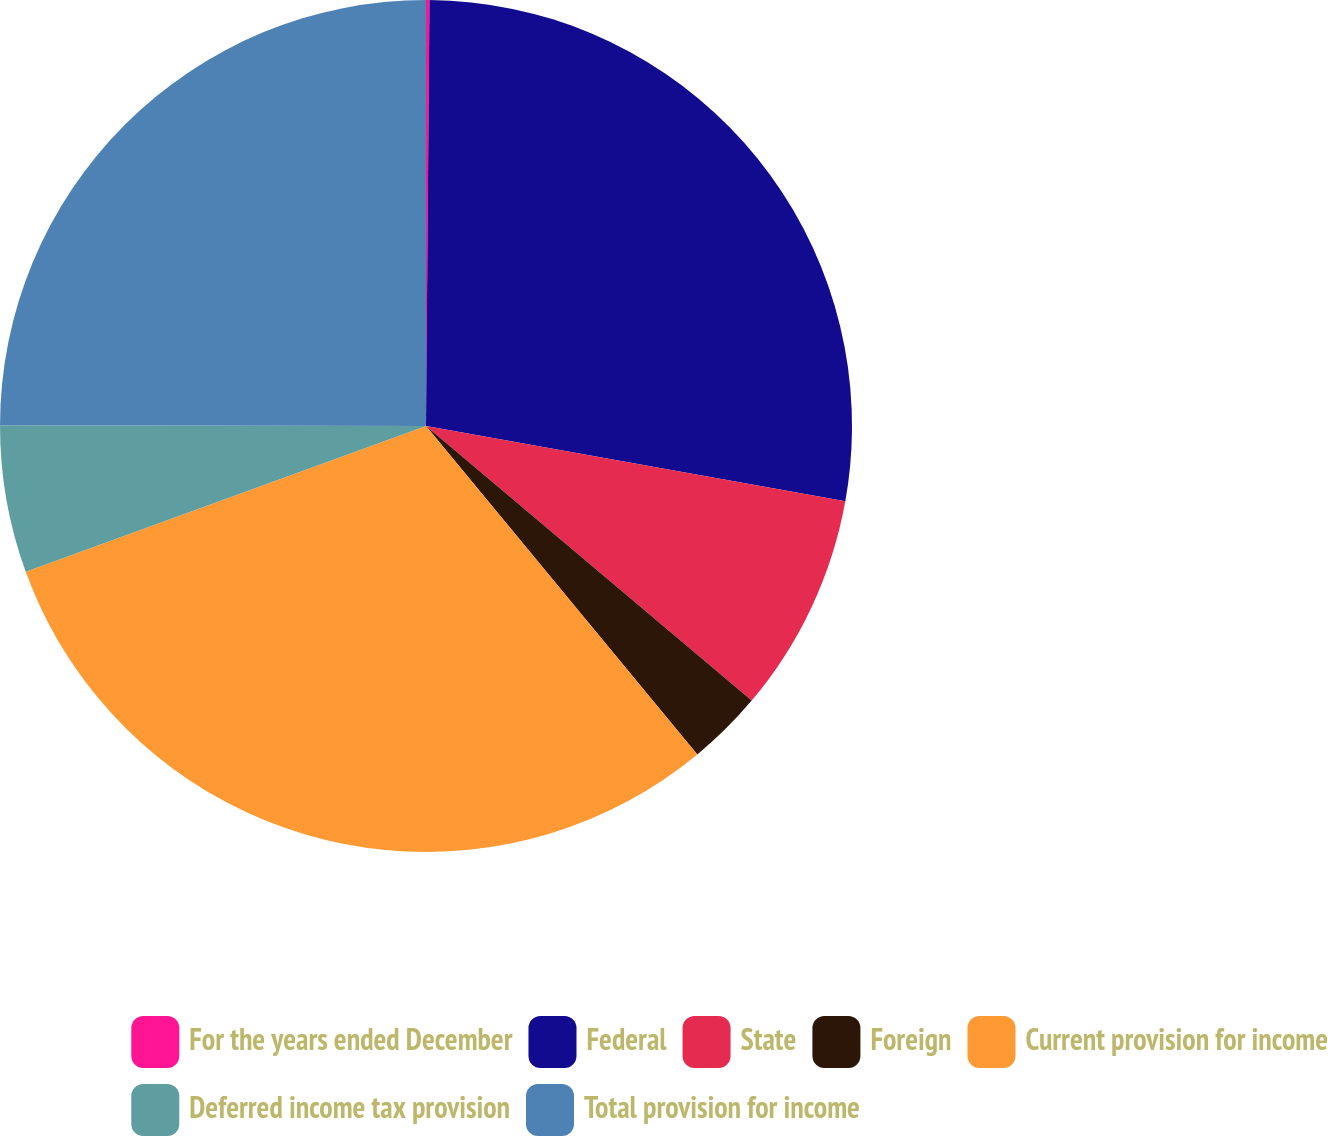<chart> <loc_0><loc_0><loc_500><loc_500><pie_chart><fcel>For the years ended December<fcel>Federal<fcel>State<fcel>Foreign<fcel>Current provision for income<fcel>Deferred income tax provision<fcel>Total provision for income<nl><fcel>0.13%<fcel>27.7%<fcel>8.32%<fcel>2.86%<fcel>30.43%<fcel>5.59%<fcel>24.97%<nl></chart> 